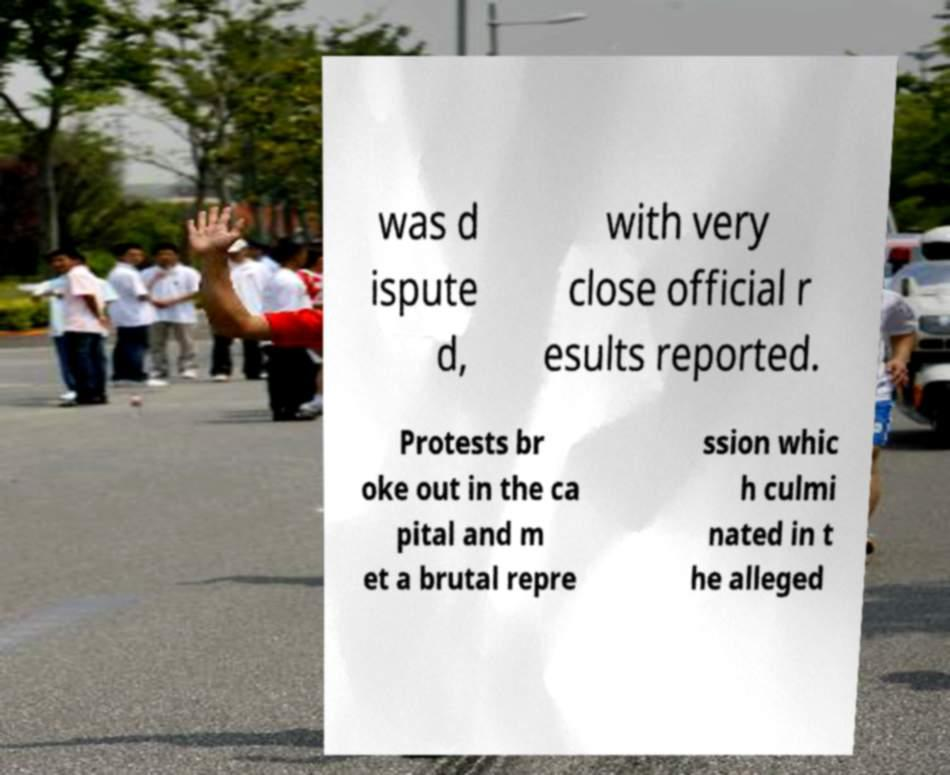I need the written content from this picture converted into text. Can you do that? was d ispute d, with very close official r esults reported. Protests br oke out in the ca pital and m et a brutal repre ssion whic h culmi nated in t he alleged 